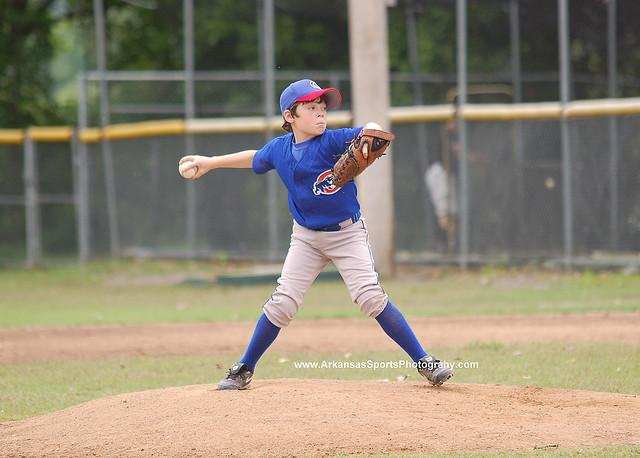Where does the URL text actually exist? Please explain your reasoning. image file. Because it is a url you can easily surmise it is a computerized photo. 